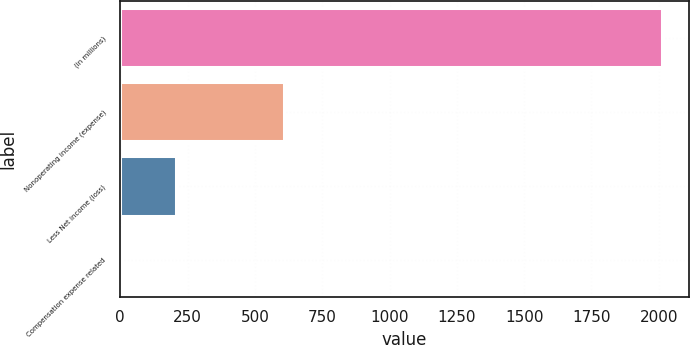Convert chart to OTSL. <chart><loc_0><loc_0><loc_500><loc_500><bar_chart><fcel>(in millions)<fcel>Nonoperating income (expense)<fcel>Less Net income (loss)<fcel>Compensation expense related<nl><fcel>2012<fcel>607.8<fcel>206.6<fcel>6<nl></chart> 